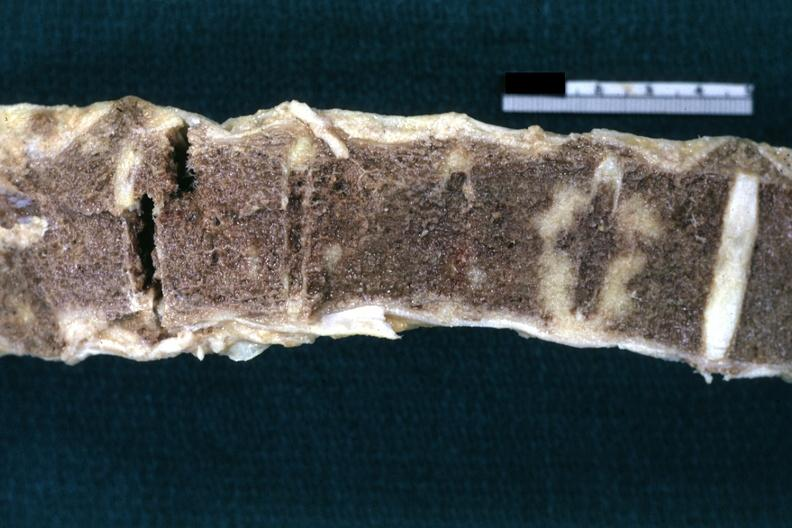does this image show fixed tissue nice example shown close-up?
Answer the question using a single word or phrase. Yes 